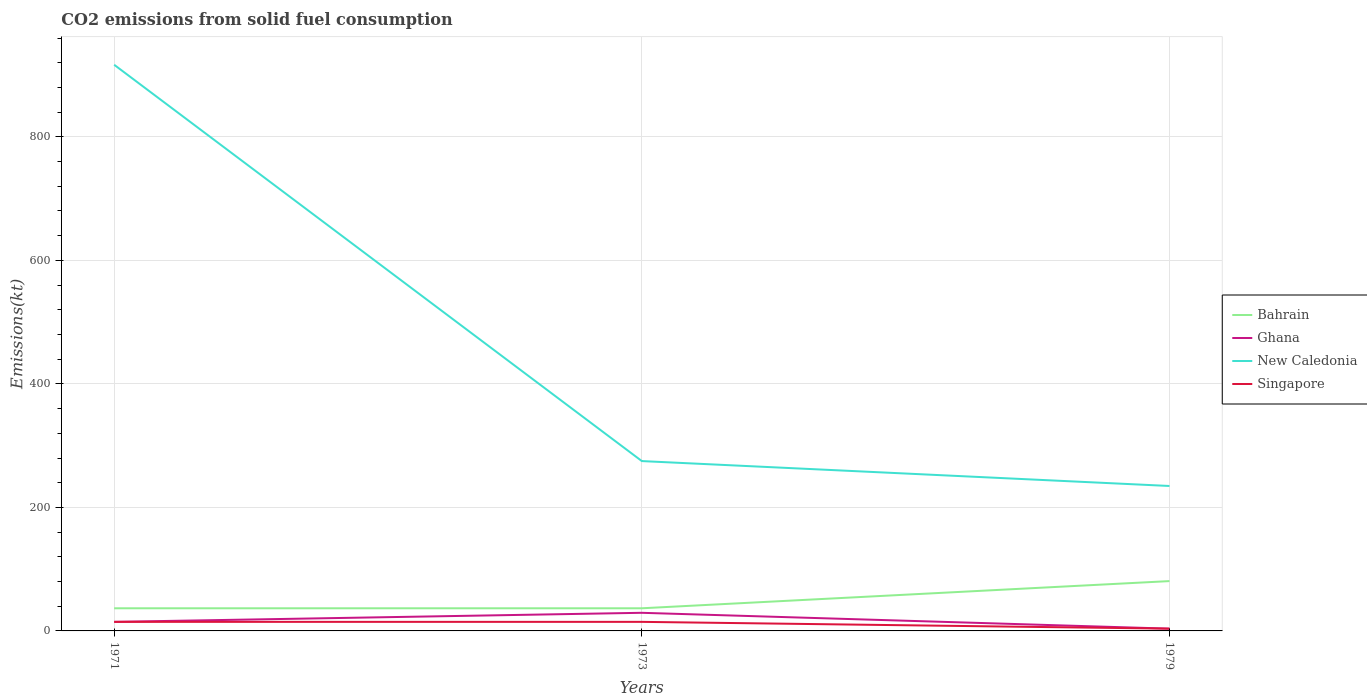How many different coloured lines are there?
Give a very brief answer. 4. Does the line corresponding to Ghana intersect with the line corresponding to Singapore?
Your answer should be compact. Yes. Is the number of lines equal to the number of legend labels?
Your answer should be compact. Yes. Across all years, what is the maximum amount of CO2 emitted in Bahrain?
Your response must be concise. 36.67. In which year was the amount of CO2 emitted in New Caledonia maximum?
Your answer should be very brief. 1979. What is the total amount of CO2 emitted in Ghana in the graph?
Make the answer very short. 25.67. What is the difference between the highest and the second highest amount of CO2 emitted in New Caledonia?
Provide a succinct answer. 682.06. Is the amount of CO2 emitted in Singapore strictly greater than the amount of CO2 emitted in Bahrain over the years?
Offer a very short reply. Yes. How many years are there in the graph?
Keep it short and to the point. 3. What is the difference between two consecutive major ticks on the Y-axis?
Offer a very short reply. 200. Are the values on the major ticks of Y-axis written in scientific E-notation?
Your answer should be compact. No. How many legend labels are there?
Your response must be concise. 4. How are the legend labels stacked?
Provide a short and direct response. Vertical. What is the title of the graph?
Give a very brief answer. CO2 emissions from solid fuel consumption. Does "Panama" appear as one of the legend labels in the graph?
Ensure brevity in your answer.  No. What is the label or title of the Y-axis?
Make the answer very short. Emissions(kt). What is the Emissions(kt) of Bahrain in 1971?
Give a very brief answer. 36.67. What is the Emissions(kt) in Ghana in 1971?
Your answer should be very brief. 14.67. What is the Emissions(kt) of New Caledonia in 1971?
Your response must be concise. 916.75. What is the Emissions(kt) in Singapore in 1971?
Provide a succinct answer. 14.67. What is the Emissions(kt) in Bahrain in 1973?
Give a very brief answer. 36.67. What is the Emissions(kt) in Ghana in 1973?
Provide a short and direct response. 29.34. What is the Emissions(kt) in New Caledonia in 1973?
Offer a terse response. 275.02. What is the Emissions(kt) in Singapore in 1973?
Ensure brevity in your answer.  14.67. What is the Emissions(kt) of Bahrain in 1979?
Your answer should be compact. 80.67. What is the Emissions(kt) in Ghana in 1979?
Make the answer very short. 3.67. What is the Emissions(kt) of New Caledonia in 1979?
Your response must be concise. 234.69. What is the Emissions(kt) in Singapore in 1979?
Your response must be concise. 3.67. Across all years, what is the maximum Emissions(kt) of Bahrain?
Provide a succinct answer. 80.67. Across all years, what is the maximum Emissions(kt) of Ghana?
Provide a succinct answer. 29.34. Across all years, what is the maximum Emissions(kt) of New Caledonia?
Provide a short and direct response. 916.75. Across all years, what is the maximum Emissions(kt) in Singapore?
Give a very brief answer. 14.67. Across all years, what is the minimum Emissions(kt) of Bahrain?
Give a very brief answer. 36.67. Across all years, what is the minimum Emissions(kt) of Ghana?
Provide a succinct answer. 3.67. Across all years, what is the minimum Emissions(kt) in New Caledonia?
Make the answer very short. 234.69. Across all years, what is the minimum Emissions(kt) of Singapore?
Offer a terse response. 3.67. What is the total Emissions(kt) in Bahrain in the graph?
Give a very brief answer. 154.01. What is the total Emissions(kt) of Ghana in the graph?
Give a very brief answer. 47.67. What is the total Emissions(kt) of New Caledonia in the graph?
Provide a short and direct response. 1426.46. What is the total Emissions(kt) of Singapore in the graph?
Your answer should be compact. 33. What is the difference between the Emissions(kt) of Ghana in 1971 and that in 1973?
Provide a short and direct response. -14.67. What is the difference between the Emissions(kt) of New Caledonia in 1971 and that in 1973?
Offer a terse response. 641.73. What is the difference between the Emissions(kt) of Bahrain in 1971 and that in 1979?
Keep it short and to the point. -44. What is the difference between the Emissions(kt) of Ghana in 1971 and that in 1979?
Ensure brevity in your answer.  11. What is the difference between the Emissions(kt) in New Caledonia in 1971 and that in 1979?
Provide a succinct answer. 682.06. What is the difference between the Emissions(kt) of Singapore in 1971 and that in 1979?
Ensure brevity in your answer.  11. What is the difference between the Emissions(kt) of Bahrain in 1973 and that in 1979?
Give a very brief answer. -44. What is the difference between the Emissions(kt) in Ghana in 1973 and that in 1979?
Your answer should be very brief. 25.67. What is the difference between the Emissions(kt) of New Caledonia in 1973 and that in 1979?
Provide a short and direct response. 40.34. What is the difference between the Emissions(kt) in Singapore in 1973 and that in 1979?
Your answer should be compact. 11. What is the difference between the Emissions(kt) of Bahrain in 1971 and the Emissions(kt) of Ghana in 1973?
Offer a very short reply. 7.33. What is the difference between the Emissions(kt) of Bahrain in 1971 and the Emissions(kt) of New Caledonia in 1973?
Provide a succinct answer. -238.35. What is the difference between the Emissions(kt) in Bahrain in 1971 and the Emissions(kt) in Singapore in 1973?
Offer a very short reply. 22. What is the difference between the Emissions(kt) in Ghana in 1971 and the Emissions(kt) in New Caledonia in 1973?
Ensure brevity in your answer.  -260.36. What is the difference between the Emissions(kt) in New Caledonia in 1971 and the Emissions(kt) in Singapore in 1973?
Keep it short and to the point. 902.08. What is the difference between the Emissions(kt) of Bahrain in 1971 and the Emissions(kt) of Ghana in 1979?
Offer a very short reply. 33. What is the difference between the Emissions(kt) in Bahrain in 1971 and the Emissions(kt) in New Caledonia in 1979?
Offer a very short reply. -198.02. What is the difference between the Emissions(kt) of Bahrain in 1971 and the Emissions(kt) of Singapore in 1979?
Your response must be concise. 33. What is the difference between the Emissions(kt) in Ghana in 1971 and the Emissions(kt) in New Caledonia in 1979?
Make the answer very short. -220.02. What is the difference between the Emissions(kt) of Ghana in 1971 and the Emissions(kt) of Singapore in 1979?
Offer a terse response. 11. What is the difference between the Emissions(kt) in New Caledonia in 1971 and the Emissions(kt) in Singapore in 1979?
Your response must be concise. 913.08. What is the difference between the Emissions(kt) in Bahrain in 1973 and the Emissions(kt) in Ghana in 1979?
Make the answer very short. 33. What is the difference between the Emissions(kt) of Bahrain in 1973 and the Emissions(kt) of New Caledonia in 1979?
Offer a terse response. -198.02. What is the difference between the Emissions(kt) in Bahrain in 1973 and the Emissions(kt) in Singapore in 1979?
Offer a terse response. 33. What is the difference between the Emissions(kt) of Ghana in 1973 and the Emissions(kt) of New Caledonia in 1979?
Provide a succinct answer. -205.35. What is the difference between the Emissions(kt) in Ghana in 1973 and the Emissions(kt) in Singapore in 1979?
Your response must be concise. 25.67. What is the difference between the Emissions(kt) in New Caledonia in 1973 and the Emissions(kt) in Singapore in 1979?
Your answer should be compact. 271.36. What is the average Emissions(kt) in Bahrain per year?
Make the answer very short. 51.34. What is the average Emissions(kt) in Ghana per year?
Offer a terse response. 15.89. What is the average Emissions(kt) of New Caledonia per year?
Your response must be concise. 475.49. What is the average Emissions(kt) of Singapore per year?
Ensure brevity in your answer.  11. In the year 1971, what is the difference between the Emissions(kt) in Bahrain and Emissions(kt) in Ghana?
Make the answer very short. 22. In the year 1971, what is the difference between the Emissions(kt) of Bahrain and Emissions(kt) of New Caledonia?
Ensure brevity in your answer.  -880.08. In the year 1971, what is the difference between the Emissions(kt) of Bahrain and Emissions(kt) of Singapore?
Your answer should be very brief. 22. In the year 1971, what is the difference between the Emissions(kt) of Ghana and Emissions(kt) of New Caledonia?
Offer a terse response. -902.08. In the year 1971, what is the difference between the Emissions(kt) in Ghana and Emissions(kt) in Singapore?
Your answer should be compact. 0. In the year 1971, what is the difference between the Emissions(kt) of New Caledonia and Emissions(kt) of Singapore?
Ensure brevity in your answer.  902.08. In the year 1973, what is the difference between the Emissions(kt) in Bahrain and Emissions(kt) in Ghana?
Offer a terse response. 7.33. In the year 1973, what is the difference between the Emissions(kt) of Bahrain and Emissions(kt) of New Caledonia?
Provide a succinct answer. -238.35. In the year 1973, what is the difference between the Emissions(kt) of Bahrain and Emissions(kt) of Singapore?
Ensure brevity in your answer.  22. In the year 1973, what is the difference between the Emissions(kt) of Ghana and Emissions(kt) of New Caledonia?
Give a very brief answer. -245.69. In the year 1973, what is the difference between the Emissions(kt) in Ghana and Emissions(kt) in Singapore?
Make the answer very short. 14.67. In the year 1973, what is the difference between the Emissions(kt) of New Caledonia and Emissions(kt) of Singapore?
Offer a terse response. 260.36. In the year 1979, what is the difference between the Emissions(kt) in Bahrain and Emissions(kt) in Ghana?
Make the answer very short. 77.01. In the year 1979, what is the difference between the Emissions(kt) in Bahrain and Emissions(kt) in New Caledonia?
Offer a terse response. -154.01. In the year 1979, what is the difference between the Emissions(kt) of Bahrain and Emissions(kt) of Singapore?
Offer a very short reply. 77.01. In the year 1979, what is the difference between the Emissions(kt) of Ghana and Emissions(kt) of New Caledonia?
Your answer should be very brief. -231.02. In the year 1979, what is the difference between the Emissions(kt) in New Caledonia and Emissions(kt) in Singapore?
Make the answer very short. 231.02. What is the ratio of the Emissions(kt) in Ghana in 1971 to that in 1973?
Your response must be concise. 0.5. What is the ratio of the Emissions(kt) of Bahrain in 1971 to that in 1979?
Make the answer very short. 0.45. What is the ratio of the Emissions(kt) of Ghana in 1971 to that in 1979?
Provide a succinct answer. 4. What is the ratio of the Emissions(kt) of New Caledonia in 1971 to that in 1979?
Your answer should be very brief. 3.91. What is the ratio of the Emissions(kt) in Bahrain in 1973 to that in 1979?
Keep it short and to the point. 0.45. What is the ratio of the Emissions(kt) of Ghana in 1973 to that in 1979?
Ensure brevity in your answer.  8. What is the ratio of the Emissions(kt) of New Caledonia in 1973 to that in 1979?
Your response must be concise. 1.17. What is the ratio of the Emissions(kt) in Singapore in 1973 to that in 1979?
Keep it short and to the point. 4. What is the difference between the highest and the second highest Emissions(kt) of Bahrain?
Offer a very short reply. 44. What is the difference between the highest and the second highest Emissions(kt) in Ghana?
Provide a short and direct response. 14.67. What is the difference between the highest and the second highest Emissions(kt) of New Caledonia?
Keep it short and to the point. 641.73. What is the difference between the highest and the lowest Emissions(kt) in Bahrain?
Ensure brevity in your answer.  44. What is the difference between the highest and the lowest Emissions(kt) of Ghana?
Your answer should be very brief. 25.67. What is the difference between the highest and the lowest Emissions(kt) of New Caledonia?
Keep it short and to the point. 682.06. What is the difference between the highest and the lowest Emissions(kt) of Singapore?
Your answer should be very brief. 11. 